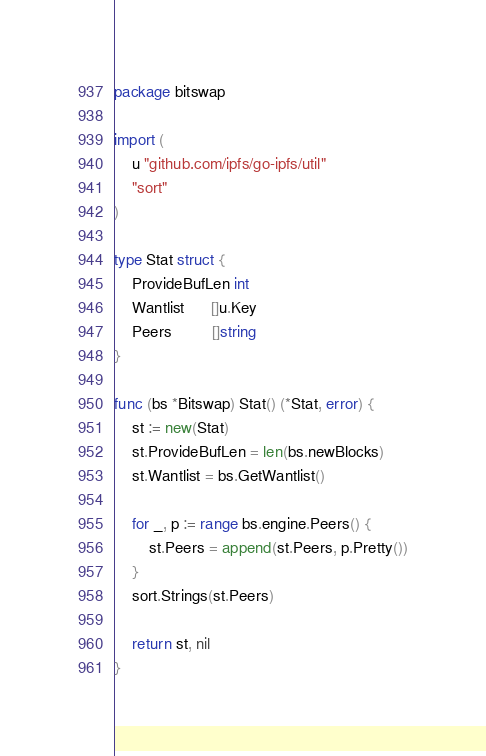Convert code to text. <code><loc_0><loc_0><loc_500><loc_500><_Go_>package bitswap

import (
	u "github.com/ipfs/go-ipfs/util"
	"sort"
)

type Stat struct {
	ProvideBufLen int
	Wantlist      []u.Key
	Peers         []string
}

func (bs *Bitswap) Stat() (*Stat, error) {
	st := new(Stat)
	st.ProvideBufLen = len(bs.newBlocks)
	st.Wantlist = bs.GetWantlist()

	for _, p := range bs.engine.Peers() {
		st.Peers = append(st.Peers, p.Pretty())
	}
	sort.Strings(st.Peers)

	return st, nil
}
</code> 